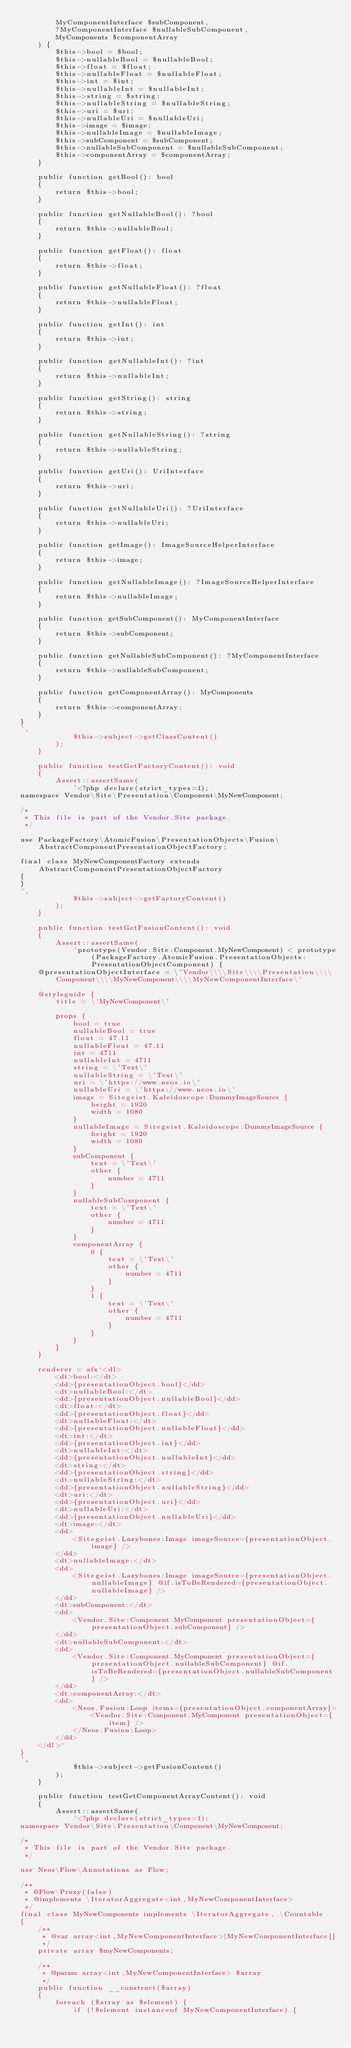<code> <loc_0><loc_0><loc_500><loc_500><_PHP_>        MyComponentInterface $subComponent,
        ?MyComponentInterface $nullableSubComponent,
        MyComponents $componentArray
    ) {
        $this->bool = $bool;
        $this->nullableBool = $nullableBool;
        $this->float = $float;
        $this->nullableFloat = $nullableFloat;
        $this->int = $int;
        $this->nullableInt = $nullableInt;
        $this->string = $string;
        $this->nullableString = $nullableString;
        $this->uri = $uri;
        $this->nullableUri = $nullableUri;
        $this->image = $image;
        $this->nullableImage = $nullableImage;
        $this->subComponent = $subComponent;
        $this->nullableSubComponent = $nullableSubComponent;
        $this->componentArray = $componentArray;
    }

    public function getBool(): bool
    {
        return $this->bool;
    }

    public function getNullableBool(): ?bool
    {
        return $this->nullableBool;
    }

    public function getFloat(): float
    {
        return $this->float;
    }

    public function getNullableFloat(): ?float
    {
        return $this->nullableFloat;
    }

    public function getInt(): int
    {
        return $this->int;
    }

    public function getNullableInt(): ?int
    {
        return $this->nullableInt;
    }

    public function getString(): string
    {
        return $this->string;
    }

    public function getNullableString(): ?string
    {
        return $this->nullableString;
    }

    public function getUri(): UriInterface
    {
        return $this->uri;
    }

    public function getNullableUri(): ?UriInterface
    {
        return $this->nullableUri;
    }

    public function getImage(): ImageSourceHelperInterface
    {
        return $this->image;
    }

    public function getNullableImage(): ?ImageSourceHelperInterface
    {
        return $this->nullableImage;
    }

    public function getSubComponent(): MyComponentInterface
    {
        return $this->subComponent;
    }

    public function getNullableSubComponent(): ?MyComponentInterface
    {
        return $this->nullableSubComponent;
    }

    public function getComponentArray(): MyComponents
    {
        return $this->componentArray;
    }
}
',
            $this->subject->getClassContent()
        );
    }

    public function testGetFactoryContent(): void
    {
        Assert::assertSame(
            '<?php declare(strict_types=1);
namespace Vendor\Site\Presentation\Component\MyNewComponent;

/*
 * This file is part of the Vendor.Site package.
 */

use PackageFactory\AtomicFusion\PresentationObjects\Fusion\AbstractComponentPresentationObjectFactory;

final class MyNewComponentFactory extends AbstractComponentPresentationObjectFactory
{
}
',
            $this->subject->getFactoryContent()
        );
    }

    public function testGetFusionContent(): void
    {
        Assert::assertSame(
            'prototype(Vendor.Site:Component.MyNewComponent) < prototype(PackageFactory.AtomicFusion.PresentationObjects:PresentationObjectComponent) {
    @presentationObjectInterface = \'Vendor\\\\Site\\\\Presentation\\\\Component\\\\MyNewComponent\\\\MyNewComponentInterface\'

    @styleguide {
        title = \'MyNewComponent\'

        props {
            bool = true
            nullableBool = true
            float = 47.11
            nullableFloat = 47.11
            int = 4711
            nullableInt = 4711
            string = \'Text\'
            nullableString = \'Text\'
            uri = \'https://www.neos.io\'
            nullableUri = \'https://www.neos.io\'
            image = Sitegeist.Kaleidoscope:DummyImageSource {
                height = 1920
                width = 1080
            }
            nullableImage = Sitegeist.Kaleidoscope:DummyImageSource {
                height = 1920
                width = 1080
            }
            subComponent {
                text = \'Text\'
                other {
                    number = 4711
                }
            }
            nullableSubComponent {
                text = \'Text\'
                other {
                    number = 4711
                }
            }
            componentArray {
                0 {
                    text = \'Text\'
                    other {
                        number = 4711
                    }
                }
                1 {
                    text = \'Text\'
                    other {
                        number = 4711
                    }
                }
            }
        }
    }

    renderer = afx`<dl>
        <dt>bool:</dt>
        <dd>{presentationObject.bool}</dd>
        <dt>nullableBool:</dt>
        <dd>{presentationObject.nullableBool}</dd>
        <dt>float:</dt>
        <dd>{presentationObject.float}</dd>
        <dt>nullableFloat:</dt>
        <dd>{presentationObject.nullableFloat}</dd>
        <dt>int:</dt>
        <dd>{presentationObject.int}</dd>
        <dt>nullableInt:</dt>
        <dd>{presentationObject.nullableInt}</dd>
        <dt>string:</dt>
        <dd>{presentationObject.string}</dd>
        <dt>nullableString:</dt>
        <dd>{presentationObject.nullableString}</dd>
        <dt>uri:</dt>
        <dd>{presentationObject.uri}</dd>
        <dt>nullableUri:</dt>
        <dd>{presentationObject.nullableUri}</dd>
        <dt>image:</dt>
        <dd>
            <Sitegeist.Lazybones:Image imageSource={presentationObject.image} />
        </dd>
        <dt>nullableImage:</dt>
        <dd>
            <Sitegeist.Lazybones:Image imageSource={presentationObject.nullableImage} @if.isToBeRendered={presentationObject.nullableImage} />
        </dd>
        <dt>subComponent:</dt>
        <dd>
            <Vendor.Site:Component.MyComponent presentationObject={presentationObject.subComponent} />
        </dd>
        <dt>nullableSubComponent:</dt>
        <dd>
            <Vendor.Site:Component.MyComponent presentationObject={presentationObject.nullableSubComponent} @if.isToBeRendered={presentationObject.nullableSubComponent} />
        </dd>
        <dt>componentArray:</dt>
        <dd>
            <Neos.Fusion:Loop items={presentationObject.componentArray}>
                <Vendor.Site:Component.MyComponent presentationObject={item} />
            </Neos.Fusion:Loop>
        </dd>
    </dl>`
}
',
            $this->subject->getFusionContent()
        );
    }

    public function testGetComponentArrayContent(): void
    {
        Assert::assertSame(
            '<?php declare(strict_types=1);
namespace Vendor\Site\Presentation\Component\MyNewComponent;

/*
 * This file is part of the Vendor.Site package.
 */

use Neos\Flow\Annotations as Flow;

/**
 * @Flow\Proxy(false)
 * @implements \IteratorAggregate<int,MyNewComponentInterface>
 */
final class MyNewComponents implements \IteratorAggregate, \Countable
{
    /**
     * @var array<int,MyNewComponentInterface>|MyNewComponentInterface[]
     */
    private array $myNewComponents;

    /**
     * @param array<int,MyNewComponentInterface> $array
     */
    public function __construct($array)
    {
        foreach ($array as $element) {
            if (!$element instanceof MyNewComponentInterface) {</code> 